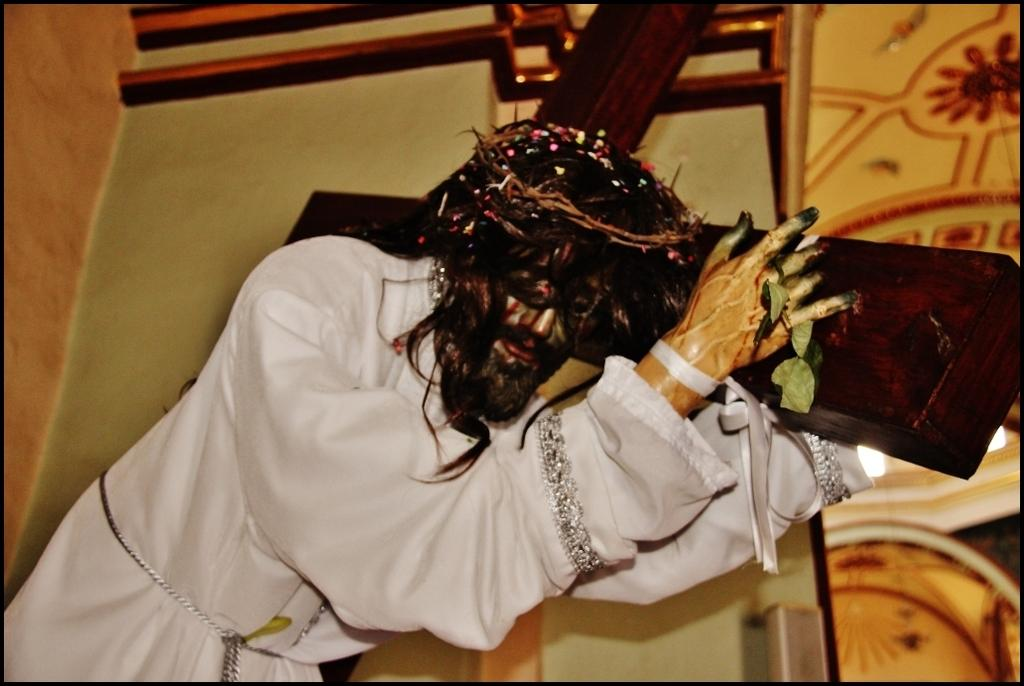What is the main subject of the image? The main subject of the image is a Jesus statue with a cross. Where is the statue located in relation to other elements in the image? The statue is near a wall. What type of vegetation can be seen in the image? There are leaves in the image. What can be seen on a surface in the image? There are objects on a surface in the image. How would you describe the background of the image? The background of the image features a designed wall. What type of lead can be seen in the image? There is no lead present in the image. What color is the paint on the Jesus statue? The provided facts do not mention the color of the statue or any paint, so it cannot be determined from the image. 